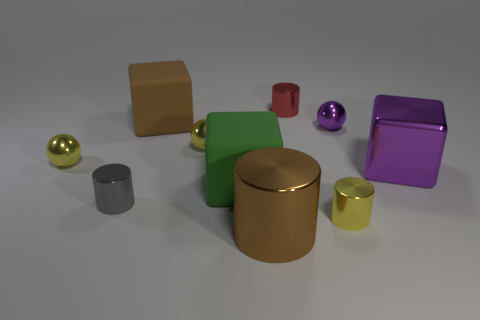What textures do the objects have, besides being matte or shiny? Aside from their matte or shiny finishes, all objects appear to have smooth textures without any noticeable patterns or roughness, contributing to the simplicity and clarity of their geometric forms. Do the textures affect the perception of the objects? Absolutely, the texture of each object influences how light interacts with the surface, which in turn affects the viewer's perception of its three-dimensionality and material composition. 